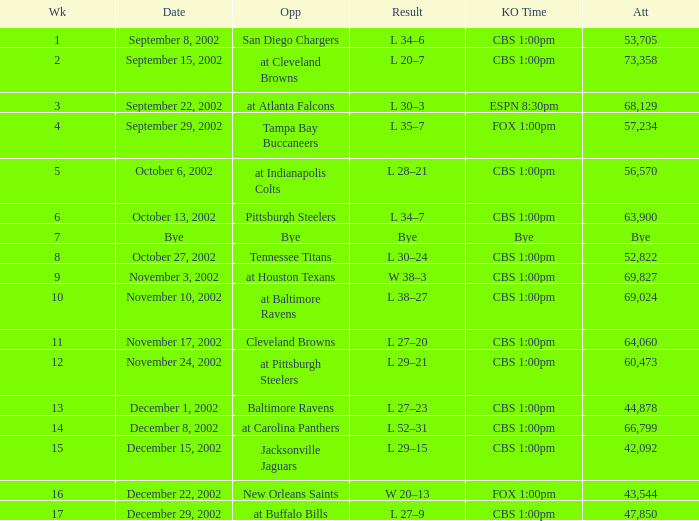What is the result of the game with 57,234 people in attendance? L 35–7. 